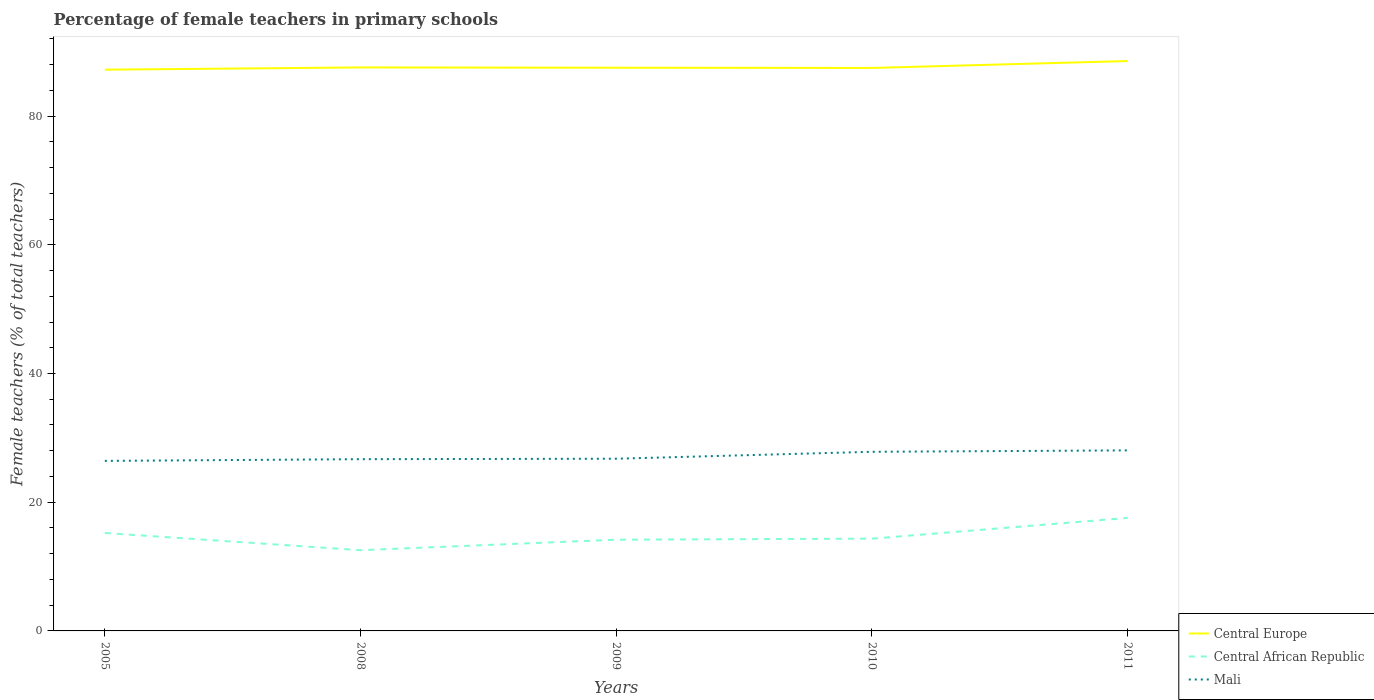Across all years, what is the maximum percentage of female teachers in Central Europe?
Offer a terse response. 87.21. What is the total percentage of female teachers in Central Europe in the graph?
Offer a very short reply. -1.34. What is the difference between the highest and the second highest percentage of female teachers in Mali?
Your response must be concise. 1.63. What is the difference between the highest and the lowest percentage of female teachers in Central African Republic?
Offer a very short reply. 2. Is the percentage of female teachers in Central Europe strictly greater than the percentage of female teachers in Mali over the years?
Your answer should be compact. No. How many lines are there?
Your answer should be very brief. 3. How many years are there in the graph?
Your response must be concise. 5. Where does the legend appear in the graph?
Offer a very short reply. Bottom right. How many legend labels are there?
Ensure brevity in your answer.  3. How are the legend labels stacked?
Provide a succinct answer. Vertical. What is the title of the graph?
Offer a terse response. Percentage of female teachers in primary schools. What is the label or title of the Y-axis?
Give a very brief answer. Female teachers (% of total teachers). What is the Female teachers (% of total teachers) in Central Europe in 2005?
Your answer should be very brief. 87.21. What is the Female teachers (% of total teachers) in Central African Republic in 2005?
Keep it short and to the point. 15.22. What is the Female teachers (% of total teachers) in Mali in 2005?
Offer a very short reply. 26.42. What is the Female teachers (% of total teachers) in Central Europe in 2008?
Offer a terse response. 87.55. What is the Female teachers (% of total teachers) of Central African Republic in 2008?
Your response must be concise. 12.55. What is the Female teachers (% of total teachers) in Mali in 2008?
Provide a short and direct response. 26.69. What is the Female teachers (% of total teachers) in Central Europe in 2009?
Your answer should be compact. 87.51. What is the Female teachers (% of total teachers) of Central African Republic in 2009?
Your answer should be very brief. 14.17. What is the Female teachers (% of total teachers) of Mali in 2009?
Offer a terse response. 26.76. What is the Female teachers (% of total teachers) of Central Europe in 2010?
Your answer should be compact. 87.47. What is the Female teachers (% of total teachers) of Central African Republic in 2010?
Provide a succinct answer. 14.34. What is the Female teachers (% of total teachers) in Mali in 2010?
Offer a terse response. 27.83. What is the Female teachers (% of total teachers) of Central Europe in 2011?
Your answer should be compact. 88.55. What is the Female teachers (% of total teachers) of Central African Republic in 2011?
Make the answer very short. 17.56. What is the Female teachers (% of total teachers) of Mali in 2011?
Provide a succinct answer. 28.05. Across all years, what is the maximum Female teachers (% of total teachers) in Central Europe?
Give a very brief answer. 88.55. Across all years, what is the maximum Female teachers (% of total teachers) of Central African Republic?
Your answer should be very brief. 17.56. Across all years, what is the maximum Female teachers (% of total teachers) in Mali?
Make the answer very short. 28.05. Across all years, what is the minimum Female teachers (% of total teachers) in Central Europe?
Offer a terse response. 87.21. Across all years, what is the minimum Female teachers (% of total teachers) in Central African Republic?
Make the answer very short. 12.55. Across all years, what is the minimum Female teachers (% of total teachers) of Mali?
Your answer should be compact. 26.42. What is the total Female teachers (% of total teachers) of Central Europe in the graph?
Give a very brief answer. 438.29. What is the total Female teachers (% of total teachers) in Central African Republic in the graph?
Your answer should be compact. 73.83. What is the total Female teachers (% of total teachers) in Mali in the graph?
Offer a terse response. 135.75. What is the difference between the Female teachers (% of total teachers) of Central Europe in 2005 and that in 2008?
Give a very brief answer. -0.35. What is the difference between the Female teachers (% of total teachers) in Central African Republic in 2005 and that in 2008?
Offer a terse response. 2.67. What is the difference between the Female teachers (% of total teachers) of Mali in 2005 and that in 2008?
Your answer should be compact. -0.27. What is the difference between the Female teachers (% of total teachers) of Central Europe in 2005 and that in 2009?
Offer a very short reply. -0.3. What is the difference between the Female teachers (% of total teachers) of Central African Republic in 2005 and that in 2009?
Your response must be concise. 1.04. What is the difference between the Female teachers (% of total teachers) of Mali in 2005 and that in 2009?
Your answer should be compact. -0.34. What is the difference between the Female teachers (% of total teachers) of Central Europe in 2005 and that in 2010?
Provide a short and direct response. -0.27. What is the difference between the Female teachers (% of total teachers) of Central African Republic in 2005 and that in 2010?
Give a very brief answer. 0.88. What is the difference between the Female teachers (% of total teachers) in Mali in 2005 and that in 2010?
Provide a short and direct response. -1.41. What is the difference between the Female teachers (% of total teachers) in Central Europe in 2005 and that in 2011?
Give a very brief answer. -1.34. What is the difference between the Female teachers (% of total teachers) in Central African Republic in 2005 and that in 2011?
Make the answer very short. -2.34. What is the difference between the Female teachers (% of total teachers) of Mali in 2005 and that in 2011?
Give a very brief answer. -1.63. What is the difference between the Female teachers (% of total teachers) of Central Europe in 2008 and that in 2009?
Your response must be concise. 0.05. What is the difference between the Female teachers (% of total teachers) of Central African Republic in 2008 and that in 2009?
Keep it short and to the point. -1.63. What is the difference between the Female teachers (% of total teachers) of Mali in 2008 and that in 2009?
Give a very brief answer. -0.07. What is the difference between the Female teachers (% of total teachers) in Central Europe in 2008 and that in 2010?
Keep it short and to the point. 0.08. What is the difference between the Female teachers (% of total teachers) of Central African Republic in 2008 and that in 2010?
Your answer should be very brief. -1.79. What is the difference between the Female teachers (% of total teachers) in Mali in 2008 and that in 2010?
Your answer should be very brief. -1.15. What is the difference between the Female teachers (% of total teachers) of Central Europe in 2008 and that in 2011?
Give a very brief answer. -0.99. What is the difference between the Female teachers (% of total teachers) of Central African Republic in 2008 and that in 2011?
Ensure brevity in your answer.  -5.01. What is the difference between the Female teachers (% of total teachers) in Mali in 2008 and that in 2011?
Offer a very short reply. -1.37. What is the difference between the Female teachers (% of total teachers) in Central Europe in 2009 and that in 2010?
Ensure brevity in your answer.  0.04. What is the difference between the Female teachers (% of total teachers) in Central African Republic in 2009 and that in 2010?
Offer a very short reply. -0.16. What is the difference between the Female teachers (% of total teachers) of Mali in 2009 and that in 2010?
Give a very brief answer. -1.08. What is the difference between the Female teachers (% of total teachers) of Central Europe in 2009 and that in 2011?
Your answer should be very brief. -1.04. What is the difference between the Female teachers (% of total teachers) in Central African Republic in 2009 and that in 2011?
Your answer should be very brief. -3.38. What is the difference between the Female teachers (% of total teachers) of Mali in 2009 and that in 2011?
Your response must be concise. -1.3. What is the difference between the Female teachers (% of total teachers) of Central Europe in 2010 and that in 2011?
Your response must be concise. -1.08. What is the difference between the Female teachers (% of total teachers) in Central African Republic in 2010 and that in 2011?
Your answer should be compact. -3.22. What is the difference between the Female teachers (% of total teachers) in Mali in 2010 and that in 2011?
Provide a short and direct response. -0.22. What is the difference between the Female teachers (% of total teachers) in Central Europe in 2005 and the Female teachers (% of total teachers) in Central African Republic in 2008?
Your response must be concise. 74.66. What is the difference between the Female teachers (% of total teachers) in Central Europe in 2005 and the Female teachers (% of total teachers) in Mali in 2008?
Provide a succinct answer. 60.52. What is the difference between the Female teachers (% of total teachers) of Central African Republic in 2005 and the Female teachers (% of total teachers) of Mali in 2008?
Your response must be concise. -11.47. What is the difference between the Female teachers (% of total teachers) of Central Europe in 2005 and the Female teachers (% of total teachers) of Central African Republic in 2009?
Offer a terse response. 73.03. What is the difference between the Female teachers (% of total teachers) in Central Europe in 2005 and the Female teachers (% of total teachers) in Mali in 2009?
Make the answer very short. 60.45. What is the difference between the Female teachers (% of total teachers) in Central African Republic in 2005 and the Female teachers (% of total teachers) in Mali in 2009?
Provide a succinct answer. -11.54. What is the difference between the Female teachers (% of total teachers) of Central Europe in 2005 and the Female teachers (% of total teachers) of Central African Republic in 2010?
Keep it short and to the point. 72.87. What is the difference between the Female teachers (% of total teachers) of Central Europe in 2005 and the Female teachers (% of total teachers) of Mali in 2010?
Your answer should be compact. 59.37. What is the difference between the Female teachers (% of total teachers) in Central African Republic in 2005 and the Female teachers (% of total teachers) in Mali in 2010?
Offer a very short reply. -12.62. What is the difference between the Female teachers (% of total teachers) in Central Europe in 2005 and the Female teachers (% of total teachers) in Central African Republic in 2011?
Your response must be concise. 69.65. What is the difference between the Female teachers (% of total teachers) of Central Europe in 2005 and the Female teachers (% of total teachers) of Mali in 2011?
Make the answer very short. 59.16. What is the difference between the Female teachers (% of total teachers) of Central African Republic in 2005 and the Female teachers (% of total teachers) of Mali in 2011?
Offer a very short reply. -12.84. What is the difference between the Female teachers (% of total teachers) in Central Europe in 2008 and the Female teachers (% of total teachers) in Central African Republic in 2009?
Your answer should be compact. 73.38. What is the difference between the Female teachers (% of total teachers) in Central Europe in 2008 and the Female teachers (% of total teachers) in Mali in 2009?
Offer a very short reply. 60.8. What is the difference between the Female teachers (% of total teachers) of Central African Republic in 2008 and the Female teachers (% of total teachers) of Mali in 2009?
Offer a terse response. -14.21. What is the difference between the Female teachers (% of total teachers) of Central Europe in 2008 and the Female teachers (% of total teachers) of Central African Republic in 2010?
Ensure brevity in your answer.  73.22. What is the difference between the Female teachers (% of total teachers) in Central Europe in 2008 and the Female teachers (% of total teachers) in Mali in 2010?
Your answer should be very brief. 59.72. What is the difference between the Female teachers (% of total teachers) in Central African Republic in 2008 and the Female teachers (% of total teachers) in Mali in 2010?
Your answer should be compact. -15.29. What is the difference between the Female teachers (% of total teachers) of Central Europe in 2008 and the Female teachers (% of total teachers) of Central African Republic in 2011?
Provide a short and direct response. 70. What is the difference between the Female teachers (% of total teachers) in Central Europe in 2008 and the Female teachers (% of total teachers) in Mali in 2011?
Provide a succinct answer. 59.5. What is the difference between the Female teachers (% of total teachers) in Central African Republic in 2008 and the Female teachers (% of total teachers) in Mali in 2011?
Your answer should be compact. -15.51. What is the difference between the Female teachers (% of total teachers) in Central Europe in 2009 and the Female teachers (% of total teachers) in Central African Republic in 2010?
Your answer should be compact. 73.17. What is the difference between the Female teachers (% of total teachers) of Central Europe in 2009 and the Female teachers (% of total teachers) of Mali in 2010?
Keep it short and to the point. 59.67. What is the difference between the Female teachers (% of total teachers) of Central African Republic in 2009 and the Female teachers (% of total teachers) of Mali in 2010?
Provide a short and direct response. -13.66. What is the difference between the Female teachers (% of total teachers) in Central Europe in 2009 and the Female teachers (% of total teachers) in Central African Republic in 2011?
Offer a very short reply. 69.95. What is the difference between the Female teachers (% of total teachers) in Central Europe in 2009 and the Female teachers (% of total teachers) in Mali in 2011?
Provide a succinct answer. 59.46. What is the difference between the Female teachers (% of total teachers) in Central African Republic in 2009 and the Female teachers (% of total teachers) in Mali in 2011?
Make the answer very short. -13.88. What is the difference between the Female teachers (% of total teachers) of Central Europe in 2010 and the Female teachers (% of total teachers) of Central African Republic in 2011?
Offer a terse response. 69.92. What is the difference between the Female teachers (% of total teachers) of Central Europe in 2010 and the Female teachers (% of total teachers) of Mali in 2011?
Give a very brief answer. 59.42. What is the difference between the Female teachers (% of total teachers) of Central African Republic in 2010 and the Female teachers (% of total teachers) of Mali in 2011?
Provide a short and direct response. -13.71. What is the average Female teachers (% of total teachers) of Central Europe per year?
Give a very brief answer. 87.66. What is the average Female teachers (% of total teachers) in Central African Republic per year?
Give a very brief answer. 14.77. What is the average Female teachers (% of total teachers) in Mali per year?
Give a very brief answer. 27.15. In the year 2005, what is the difference between the Female teachers (% of total teachers) in Central Europe and Female teachers (% of total teachers) in Central African Republic?
Your answer should be very brief. 71.99. In the year 2005, what is the difference between the Female teachers (% of total teachers) in Central Europe and Female teachers (% of total teachers) in Mali?
Give a very brief answer. 60.79. In the year 2005, what is the difference between the Female teachers (% of total teachers) in Central African Republic and Female teachers (% of total teachers) in Mali?
Give a very brief answer. -11.2. In the year 2008, what is the difference between the Female teachers (% of total teachers) in Central Europe and Female teachers (% of total teachers) in Central African Republic?
Ensure brevity in your answer.  75.01. In the year 2008, what is the difference between the Female teachers (% of total teachers) in Central Europe and Female teachers (% of total teachers) in Mali?
Your response must be concise. 60.87. In the year 2008, what is the difference between the Female teachers (% of total teachers) in Central African Republic and Female teachers (% of total teachers) in Mali?
Give a very brief answer. -14.14. In the year 2009, what is the difference between the Female teachers (% of total teachers) of Central Europe and Female teachers (% of total teachers) of Central African Republic?
Your answer should be very brief. 73.33. In the year 2009, what is the difference between the Female teachers (% of total teachers) in Central Europe and Female teachers (% of total teachers) in Mali?
Ensure brevity in your answer.  60.75. In the year 2009, what is the difference between the Female teachers (% of total teachers) in Central African Republic and Female teachers (% of total teachers) in Mali?
Provide a succinct answer. -12.58. In the year 2010, what is the difference between the Female teachers (% of total teachers) of Central Europe and Female teachers (% of total teachers) of Central African Republic?
Your response must be concise. 73.13. In the year 2010, what is the difference between the Female teachers (% of total teachers) of Central Europe and Female teachers (% of total teachers) of Mali?
Your answer should be very brief. 59.64. In the year 2010, what is the difference between the Female teachers (% of total teachers) of Central African Republic and Female teachers (% of total teachers) of Mali?
Give a very brief answer. -13.5. In the year 2011, what is the difference between the Female teachers (% of total teachers) of Central Europe and Female teachers (% of total teachers) of Central African Republic?
Your answer should be very brief. 70.99. In the year 2011, what is the difference between the Female teachers (% of total teachers) of Central Europe and Female teachers (% of total teachers) of Mali?
Your answer should be compact. 60.5. In the year 2011, what is the difference between the Female teachers (% of total teachers) of Central African Republic and Female teachers (% of total teachers) of Mali?
Offer a terse response. -10.5. What is the ratio of the Female teachers (% of total teachers) in Central African Republic in 2005 to that in 2008?
Offer a terse response. 1.21. What is the ratio of the Female teachers (% of total teachers) in Central African Republic in 2005 to that in 2009?
Your response must be concise. 1.07. What is the ratio of the Female teachers (% of total teachers) in Mali in 2005 to that in 2009?
Offer a very short reply. 0.99. What is the ratio of the Female teachers (% of total teachers) in Central Europe in 2005 to that in 2010?
Keep it short and to the point. 1. What is the ratio of the Female teachers (% of total teachers) of Central African Republic in 2005 to that in 2010?
Provide a succinct answer. 1.06. What is the ratio of the Female teachers (% of total teachers) in Mali in 2005 to that in 2010?
Give a very brief answer. 0.95. What is the ratio of the Female teachers (% of total teachers) in Central Europe in 2005 to that in 2011?
Your response must be concise. 0.98. What is the ratio of the Female teachers (% of total teachers) of Central African Republic in 2005 to that in 2011?
Provide a short and direct response. 0.87. What is the ratio of the Female teachers (% of total teachers) of Mali in 2005 to that in 2011?
Provide a succinct answer. 0.94. What is the ratio of the Female teachers (% of total teachers) of Central African Republic in 2008 to that in 2009?
Ensure brevity in your answer.  0.89. What is the ratio of the Female teachers (% of total teachers) in Central Europe in 2008 to that in 2010?
Provide a short and direct response. 1. What is the ratio of the Female teachers (% of total teachers) in Central African Republic in 2008 to that in 2010?
Your response must be concise. 0.87. What is the ratio of the Female teachers (% of total teachers) of Mali in 2008 to that in 2010?
Your response must be concise. 0.96. What is the ratio of the Female teachers (% of total teachers) in Central African Republic in 2008 to that in 2011?
Ensure brevity in your answer.  0.71. What is the ratio of the Female teachers (% of total teachers) of Mali in 2008 to that in 2011?
Offer a terse response. 0.95. What is the ratio of the Female teachers (% of total teachers) of Central African Republic in 2009 to that in 2010?
Ensure brevity in your answer.  0.99. What is the ratio of the Female teachers (% of total teachers) of Mali in 2009 to that in 2010?
Your response must be concise. 0.96. What is the ratio of the Female teachers (% of total teachers) in Central Europe in 2009 to that in 2011?
Your answer should be very brief. 0.99. What is the ratio of the Female teachers (% of total teachers) of Central African Republic in 2009 to that in 2011?
Give a very brief answer. 0.81. What is the ratio of the Female teachers (% of total teachers) in Mali in 2009 to that in 2011?
Your response must be concise. 0.95. What is the ratio of the Female teachers (% of total teachers) in Central Europe in 2010 to that in 2011?
Ensure brevity in your answer.  0.99. What is the ratio of the Female teachers (% of total teachers) of Central African Republic in 2010 to that in 2011?
Offer a very short reply. 0.82. What is the difference between the highest and the second highest Female teachers (% of total teachers) of Central Europe?
Keep it short and to the point. 0.99. What is the difference between the highest and the second highest Female teachers (% of total teachers) of Central African Republic?
Your answer should be compact. 2.34. What is the difference between the highest and the second highest Female teachers (% of total teachers) of Mali?
Make the answer very short. 0.22. What is the difference between the highest and the lowest Female teachers (% of total teachers) in Central Europe?
Your answer should be very brief. 1.34. What is the difference between the highest and the lowest Female teachers (% of total teachers) in Central African Republic?
Offer a very short reply. 5.01. What is the difference between the highest and the lowest Female teachers (% of total teachers) of Mali?
Offer a terse response. 1.63. 